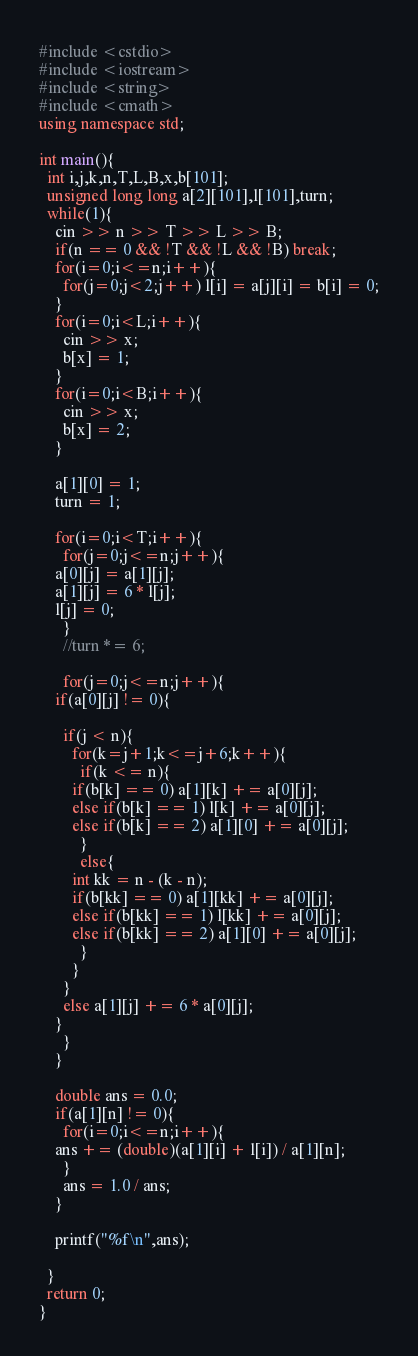<code> <loc_0><loc_0><loc_500><loc_500><_C++_>#include <cstdio>
#include <iostream>
#include <string>
#include <cmath>
using namespace std;

int main(){
  int i,j,k,n,T,L,B,x,b[101];
  unsigned long long a[2][101],l[101],turn;
  while(1){
    cin >> n >> T >> L >> B;
    if(n == 0 && !T && !L && !B) break;
    for(i=0;i<=n;i++){
      for(j=0;j<2;j++) l[i] = a[j][i] = b[i] = 0;
    }
    for(i=0;i<L;i++){
      cin >> x;
      b[x] = 1;
    }
    for(i=0;i<B;i++){
      cin >> x;
      b[x] = 2;
    }

    a[1][0] = 1;
    turn = 1;

    for(i=0;i<T;i++){
      for(j=0;j<=n;j++){
	a[0][j] = a[1][j];
	a[1][j] = 6 * l[j];
	l[j] = 0;
      }
      //turn *= 6;

      for(j=0;j<=n;j++){
	if(a[0][j] != 0){

	  if(j < n){
	    for(k=j+1;k<=j+6;k++){
	      if(k <= n){
		if(b[k] == 0) a[1][k] += a[0][j];
		else if(b[k] == 1) l[k] += a[0][j];
		else if(b[k] == 2) a[1][0] += a[0][j];
	      }
	      else{
		int kk = n - (k - n);
		if(b[kk] == 0) a[1][kk] += a[0][j];
		else if(b[kk] == 1) l[kk] += a[0][j];
		else if(b[kk] == 2) a[1][0] += a[0][j];
	      }
	    }
	  }
	  else a[1][j] += 6 * a[0][j];
	}
      }
    }

    double ans = 0.0;
    if(a[1][n] != 0){   
      for(i=0;i<=n;i++){
	ans += (double)(a[1][i] + l[i]) / a[1][n];
      }
      ans = 1.0 / ans;
    }

    printf("%f\n",ans);

  }
  return 0;
}</code> 